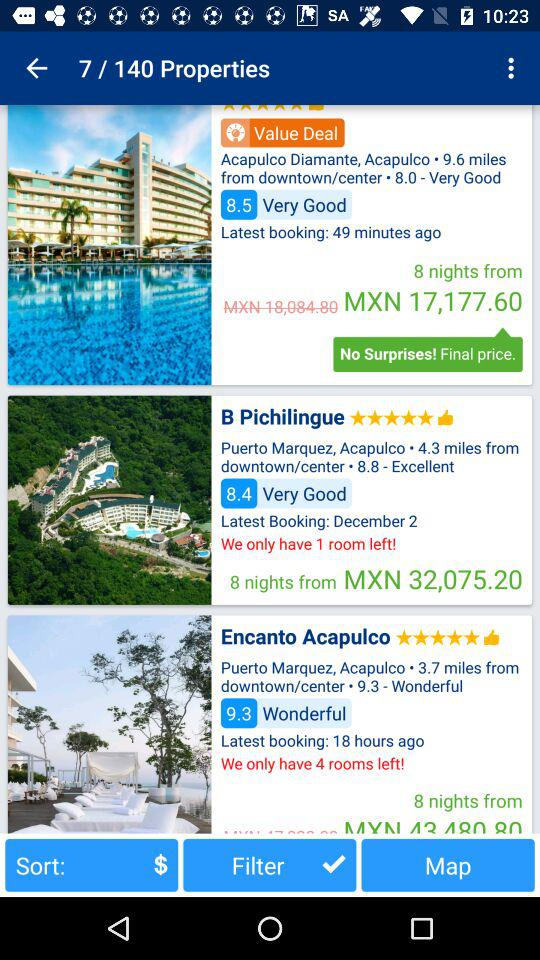How far is "B Pichilingue" from downtown/center? "B Pichilingue" is 4.3 miles away from downtown/center. 